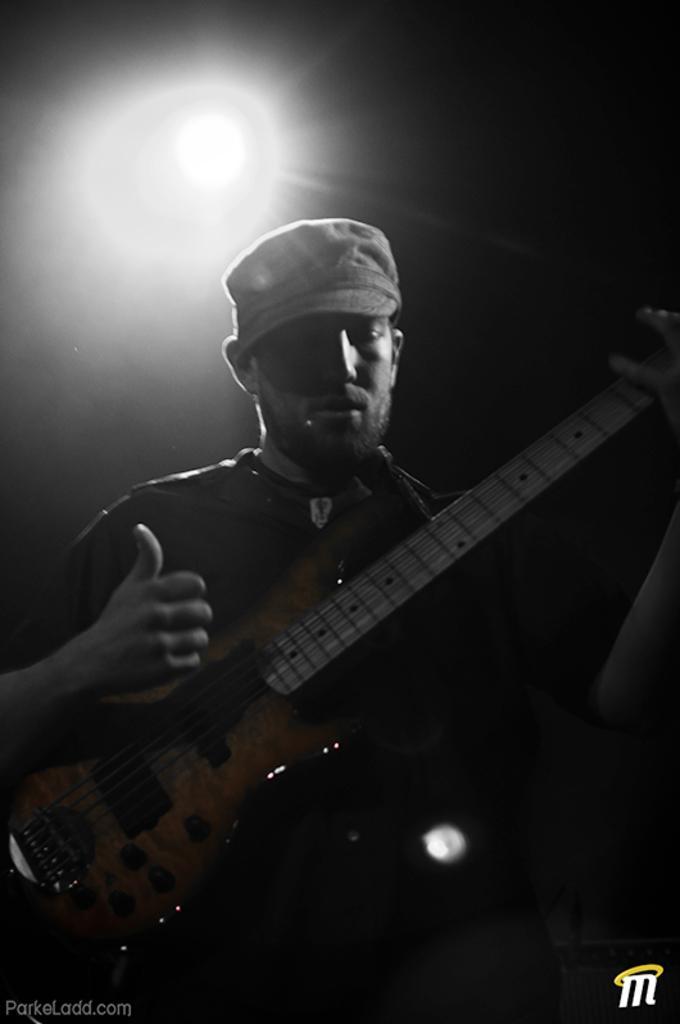How would you summarize this image in a sentence or two? Here is a man holding a guitar in his hand. 